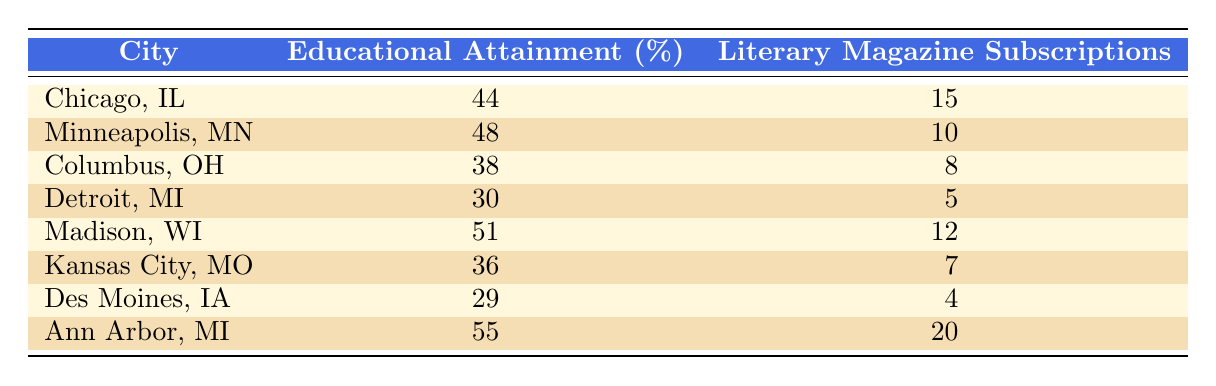What is the educational attainment percentage of Ann Arbor, MI? Referring to the table, the percentage of educational attainment for Ann Arbor, MI is listed as 55.
Answer: 55 Which city has the highest number of literary magazine subscriptions? By examining the table, Ann Arbor, MI, has the highest number of literary magazine subscriptions at 20.
Answer: Ann Arbor, MI What is the average educational attainment of the cities listed in the table? To find the average, first sum the educational attainments: 44 + 48 + 38 + 30 + 51 + 36 + 29 + 55 = 331. There are 8 cities, so the average is 331 / 8 = 41.375.
Answer: 41.375 Is the educational attainment of Minneapolis, MN, higher than that of Detroit, MI? Comparing the two values, Minneapolis has 48 and Detroit has 30. Since 48 is greater than 30, the statement is true.
Answer: Yes What is the difference in the number of literary magazine subscriptions between Chicago, IL, and Des Moines, IA? The literary magazine subscriptions for Chicago are 15 and for Des Moines, it is 4. The difference is 15 - 4 = 11.
Answer: 11 Are there any cities where the educational attainment is above 50%? Checking the educational attainment percentages: Chicago (44), Minneapolis (48), Columbus (38), Detroit (30), Madison (51), Kansas City (36), Des Moines (29), Ann Arbor (55). Madison and Ann Arbor both exceed 50%. Hence, yes.
Answer: Yes Which city has the lowest educational attainment? Looking at the table, Des Moines, IA, has the lowest educational attainment at 29%.
Answer: Des Moines, IA If we consider only the cities with educational attainment above 40%, what is the highest number of literary magazine subscriptions among them? The cities with educational attainment above 40% are Chicago (44%), Minneapolis (48%), Madison (51), and Ann Arbor (55%). Their subscriptions are 15, 10, 12, and 20, respectively. The highest is 20 (Ann Arbor).
Answer: 20 